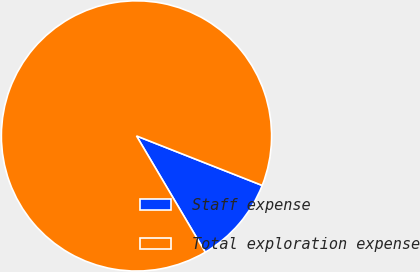<chart> <loc_0><loc_0><loc_500><loc_500><pie_chart><fcel>Staff expense<fcel>Total exploration expense<nl><fcel>10.53%<fcel>89.47%<nl></chart> 